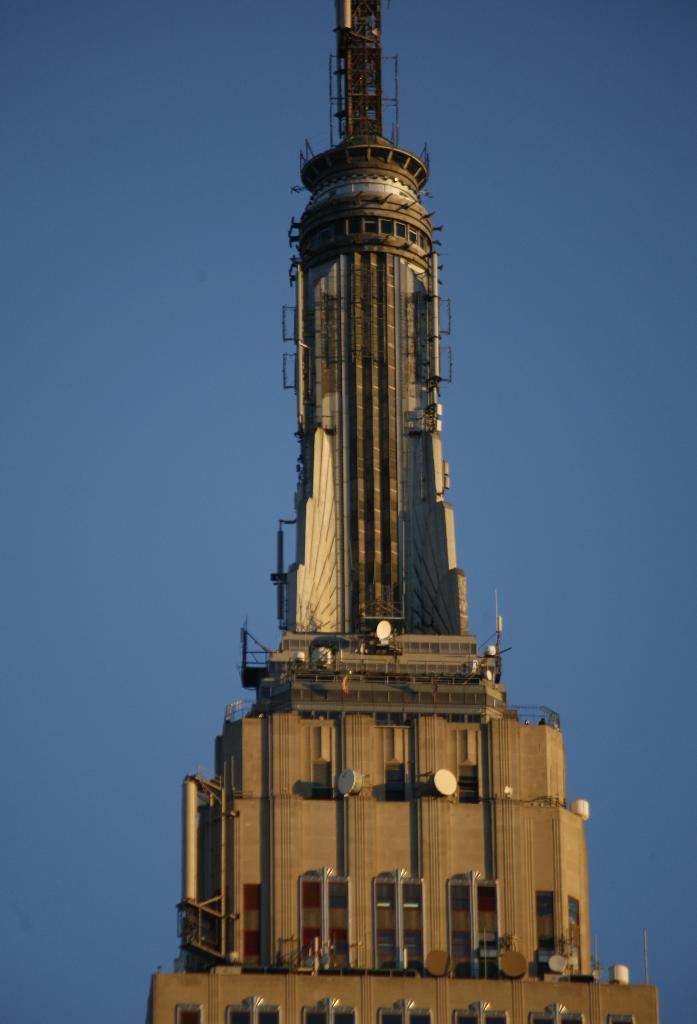What is the color of the sky in the background of the image? The sky in the background of the image is clear blue. What structure can be seen in the image? There is a tower in the image. What type of gold object is hanging from the tower in the image? There is no gold object present in the image; it only features a tower and a clear blue sky. Can you see a quill being used for writing in the image? There is no quill or writing activity depicted in the image. 